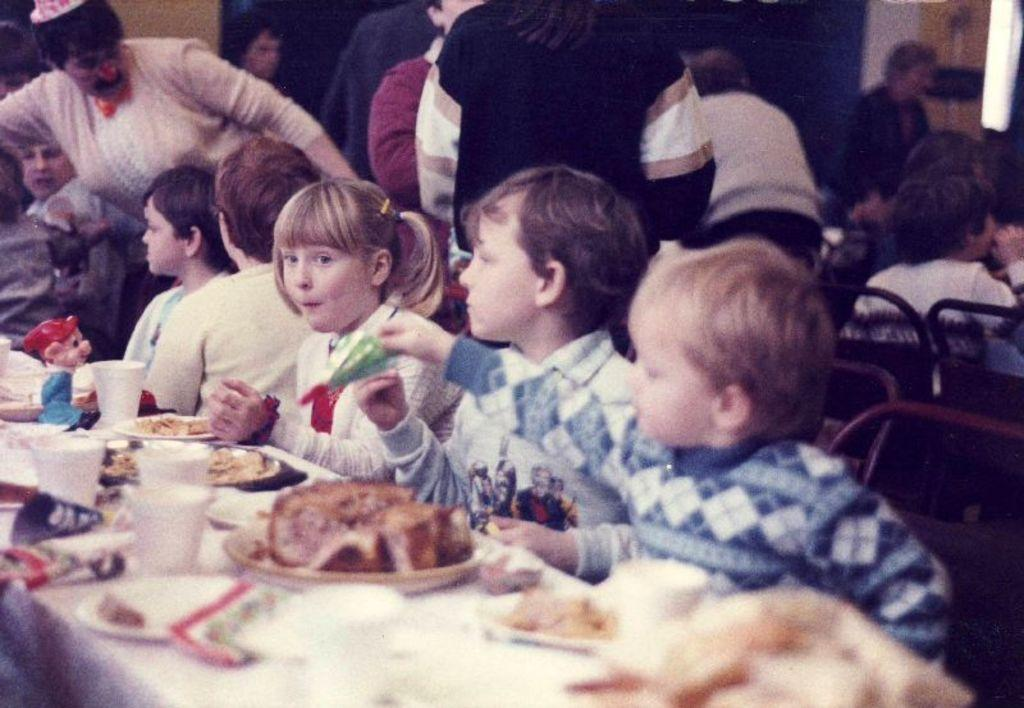How many people are in the group visible in the image? There is a group of people in the image, but the exact number cannot be determined without more specific information. What type of food can be seen on the plates and in the cups in the image? There is food on plates and cups in the image, but the specific type of food cannot be determined without more specific information. What kind of toy is on the table in the image? There is a toy on the table in the image, but the specific type of toy cannot be determined without more specific information. How many cars are parked next to the group of people in the image? There is no mention of cars in the image, so it is not possible to answer that question. Is there a pig visible in the image? There is no mention of a pig in the image, so it is not possible to answer that question. 